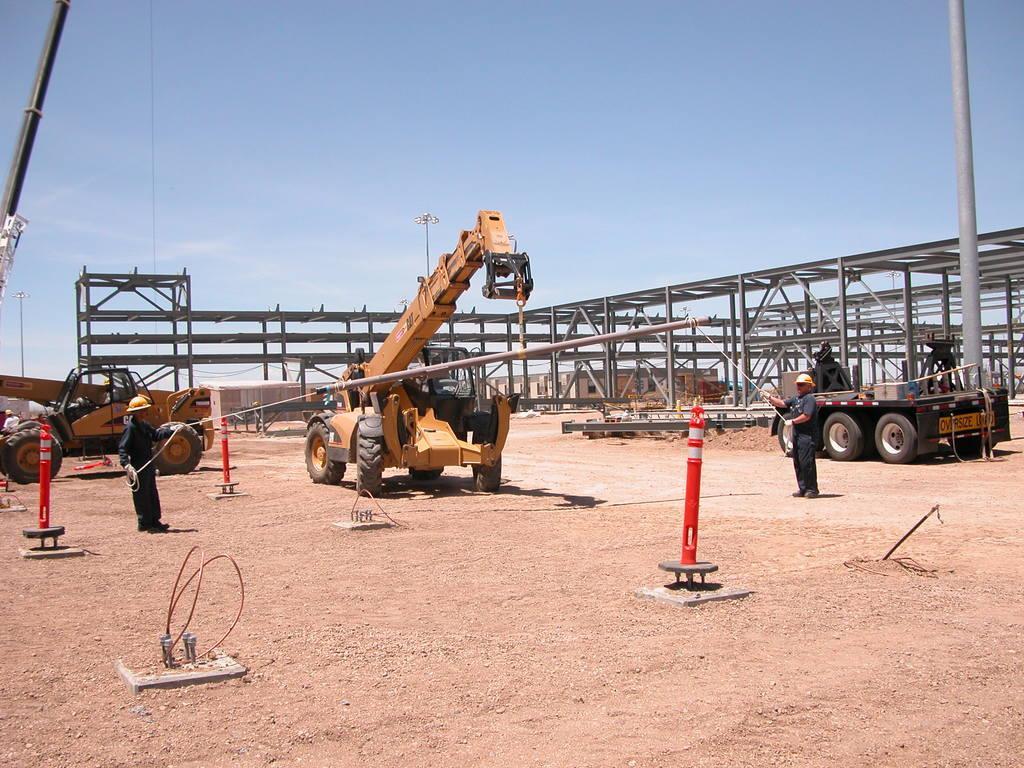Could you give a brief overview of what you see in this image? In this image we can see a group of vehicles parked on the ground. Two persons are standing and holding rope in their hand. In the background we can see a iron frame ,poles and sky. 